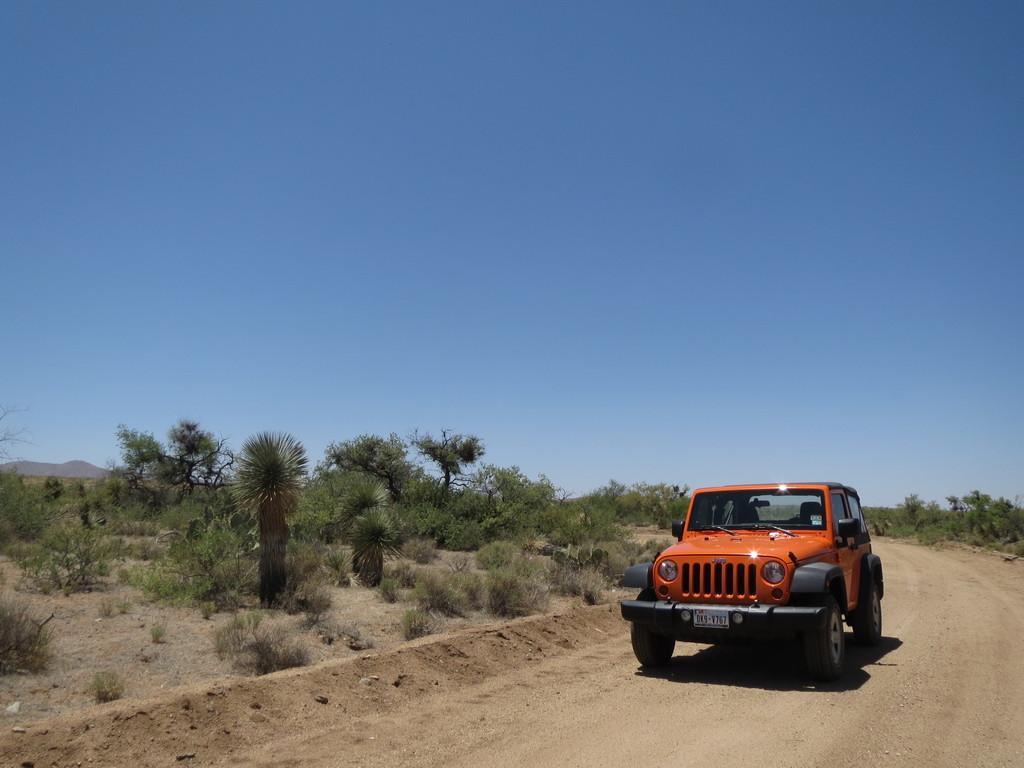Please provide a concise description of this image. In this image I can see the road, a car which is black and orange in color and few trees which are green in color. In the background I can see a mountain and the sky. 